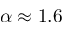<formula> <loc_0><loc_0><loc_500><loc_500>\alpha \approx 1 . 6</formula> 